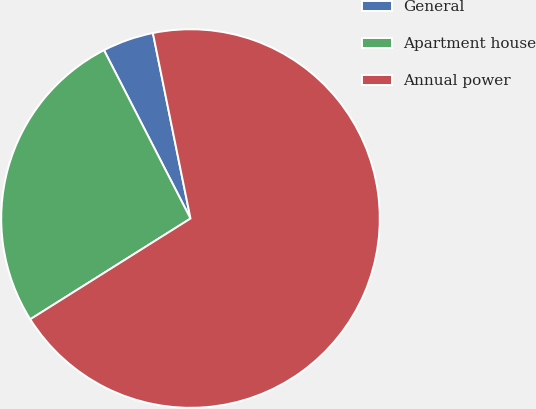<chart> <loc_0><loc_0><loc_500><loc_500><pie_chart><fcel>General<fcel>Apartment house<fcel>Annual power<nl><fcel>4.37%<fcel>26.38%<fcel>69.25%<nl></chart> 